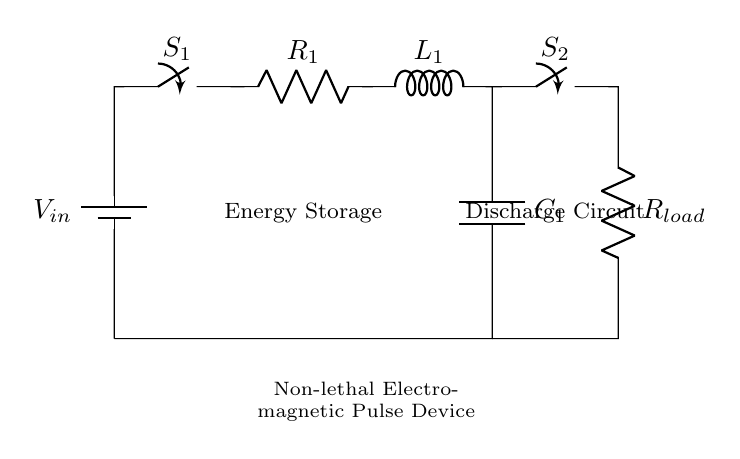What type of device is depicted in the diagram? The diagram represents a Non-lethal Electromagnetic Pulse Device, indicated by the label at the bottom of the circuit.
Answer: Non-lethal Electromagnetic Pulse Device What are the components of the energy storage section? The energy storage section includes a resistor, inductor, and capacitor, shown by the labeled symbols connected in series.
Answer: Resistor, Inductor, Capacitor What is the function of switch S1? Switch S1 controls the input voltage to the energy storage section, allowing or preventing current flow into the circuit based on its position (open or closed).
Answer: Controls input voltage How many switches are present in the circuit? There are two switches depicted in the circuit, as identified by the labels S1 and S2.
Answer: Two What happens to the energy stored in the circuit when switch S2 is closed? When switch S2 is closed, the stored energy in the capacitor will discharge through the load resistor, which allows the energy to be released for use.
Answer: Energy discharges What are the roles of the components in the discharge circuit? The load resistor (R_load) dissipates energy when S2 is closed, allowing the electromagnetic pulse to be emitted, while S2 facilitates or interrupts this pathway.
Answer: Load resistor dissipates energy How are the components connected in the energy storage section? The components in the energy storage section (R1, L1, and C1) are connected in series, meaning the current flows through each component sequentially.
Answer: In series 